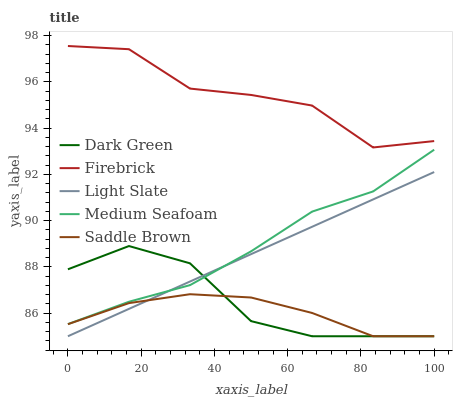Does Saddle Brown have the minimum area under the curve?
Answer yes or no. Yes. Does Firebrick have the maximum area under the curve?
Answer yes or no. Yes. Does Firebrick have the minimum area under the curve?
Answer yes or no. No. Does Saddle Brown have the maximum area under the curve?
Answer yes or no. No. Is Light Slate the smoothest?
Answer yes or no. Yes. Is Firebrick the roughest?
Answer yes or no. Yes. Is Saddle Brown the smoothest?
Answer yes or no. No. Is Saddle Brown the roughest?
Answer yes or no. No. Does Light Slate have the lowest value?
Answer yes or no. Yes. Does Firebrick have the lowest value?
Answer yes or no. No. Does Firebrick have the highest value?
Answer yes or no. Yes. Does Saddle Brown have the highest value?
Answer yes or no. No. Is Saddle Brown less than Medium Seafoam?
Answer yes or no. Yes. Is Medium Seafoam greater than Saddle Brown?
Answer yes or no. Yes. Does Medium Seafoam intersect Dark Green?
Answer yes or no. Yes. Is Medium Seafoam less than Dark Green?
Answer yes or no. No. Is Medium Seafoam greater than Dark Green?
Answer yes or no. No. Does Saddle Brown intersect Medium Seafoam?
Answer yes or no. No. 